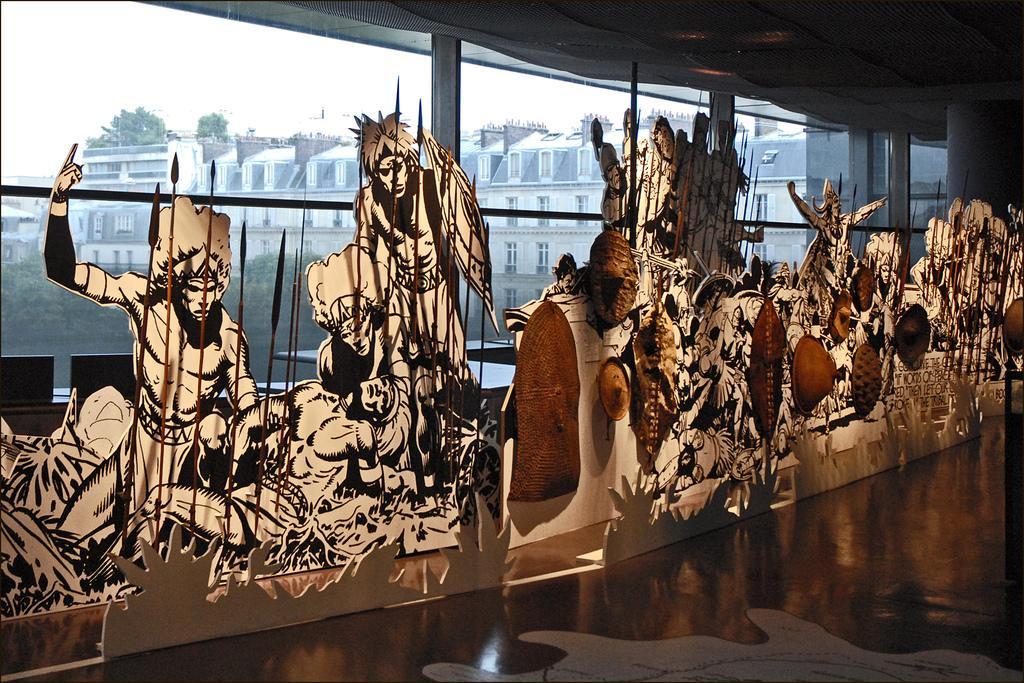Please provide a concise description of this image. In this image we can see ,there are many types of cartoon character placed one after the other on the floor, and at the back we can see the glass windows. 